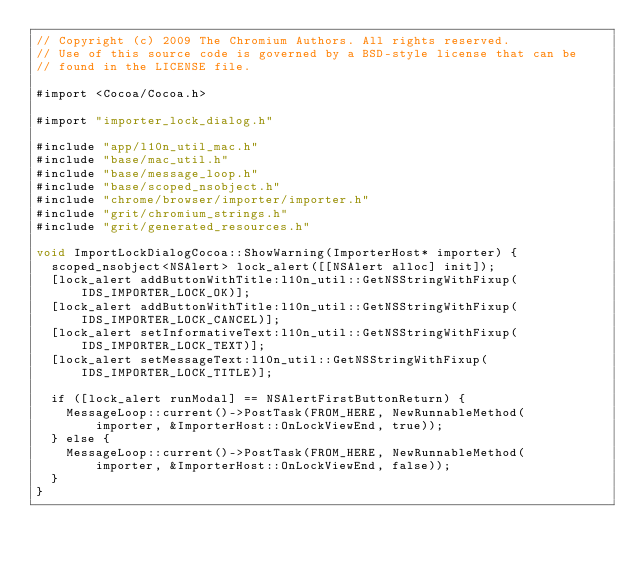Convert code to text. <code><loc_0><loc_0><loc_500><loc_500><_ObjectiveC_>// Copyright (c) 2009 The Chromium Authors. All rights reserved.
// Use of this source code is governed by a BSD-style license that can be
// found in the LICENSE file.

#import <Cocoa/Cocoa.h>

#import "importer_lock_dialog.h"

#include "app/l10n_util_mac.h"
#include "base/mac_util.h"
#include "base/message_loop.h"
#include "base/scoped_nsobject.h"
#include "chrome/browser/importer/importer.h"
#include "grit/chromium_strings.h"
#include "grit/generated_resources.h"

void ImportLockDialogCocoa::ShowWarning(ImporterHost* importer) {
  scoped_nsobject<NSAlert> lock_alert([[NSAlert alloc] init]);
  [lock_alert addButtonWithTitle:l10n_util::GetNSStringWithFixup(
      IDS_IMPORTER_LOCK_OK)];
  [lock_alert addButtonWithTitle:l10n_util::GetNSStringWithFixup(
      IDS_IMPORTER_LOCK_CANCEL)];
  [lock_alert setInformativeText:l10n_util::GetNSStringWithFixup(
      IDS_IMPORTER_LOCK_TEXT)];
  [lock_alert setMessageText:l10n_util::GetNSStringWithFixup(
      IDS_IMPORTER_LOCK_TITLE)];

  if ([lock_alert runModal] == NSAlertFirstButtonReturn) {
    MessageLoop::current()->PostTask(FROM_HERE, NewRunnableMethod(
        importer, &ImporterHost::OnLockViewEnd, true));
  } else {
    MessageLoop::current()->PostTask(FROM_HERE, NewRunnableMethod(
        importer, &ImporterHost::OnLockViewEnd, false));
  }
}
</code> 